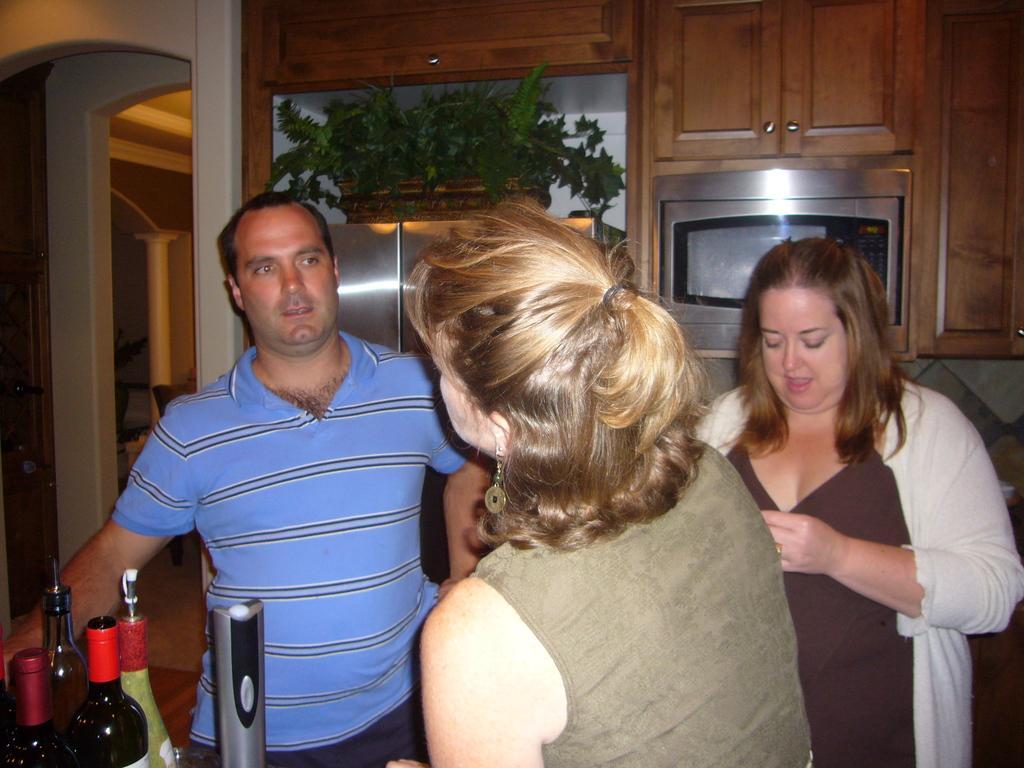Describe this image in one or two sentences. In this image there are three persons standing in the room. There are bottles at the background there is a micro-oven and cupboard and a flower pot. 